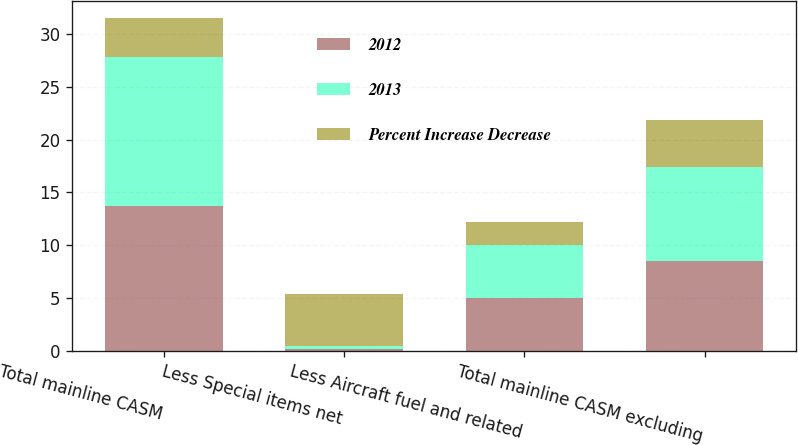<chart> <loc_0><loc_0><loc_500><loc_500><stacked_bar_chart><ecel><fcel>Total mainline CASM<fcel>Less Special items net<fcel>Less Aircraft fuel and related<fcel>Total mainline CASM excluding<nl><fcel>2012<fcel>13.67<fcel>0.18<fcel>4.94<fcel>8.5<nl><fcel>2013<fcel>14.2<fcel>0.25<fcel>5.05<fcel>8.9<nl><fcel>Percent Increase Decrease<fcel>3.7<fcel>4.94<fcel>2.2<fcel>4.5<nl></chart> 